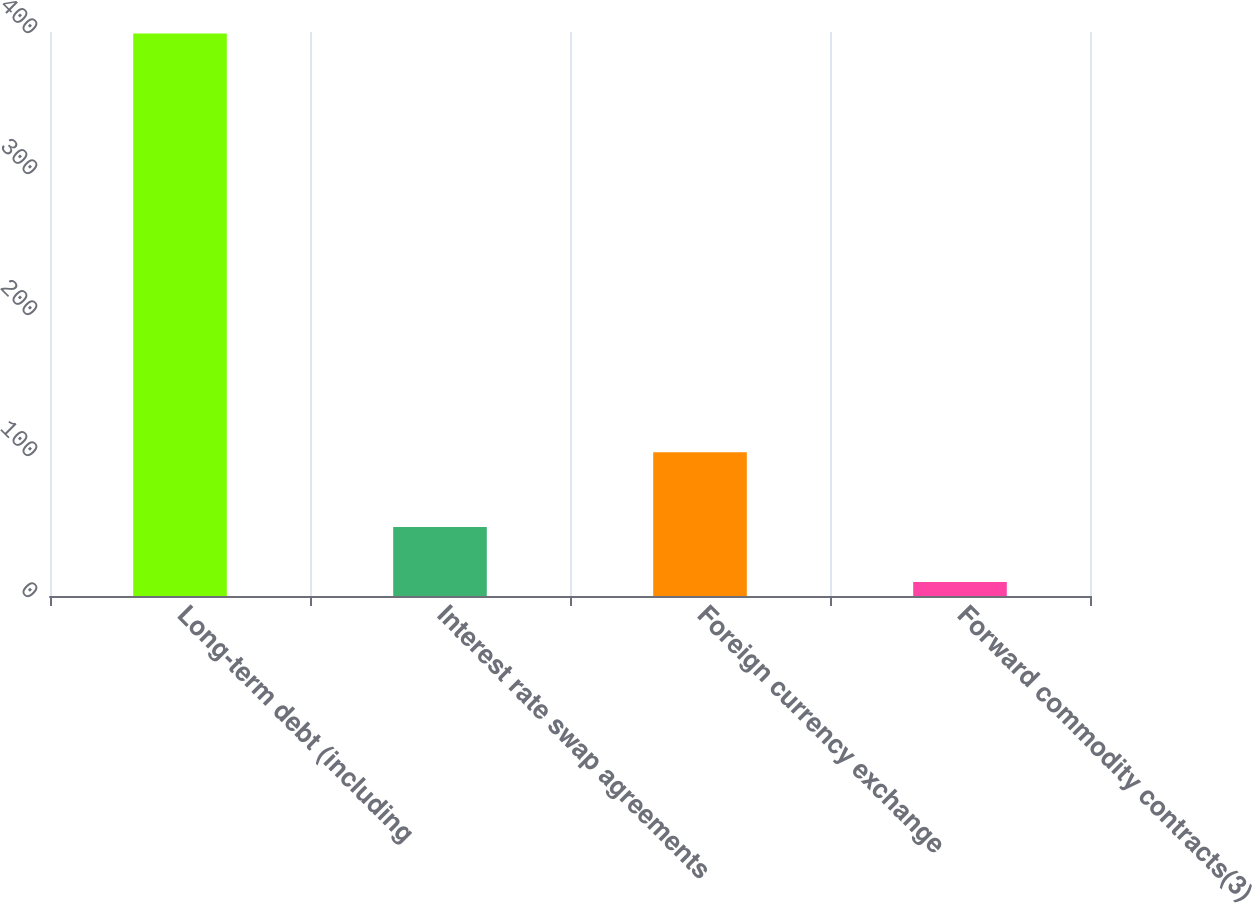Convert chart to OTSL. <chart><loc_0><loc_0><loc_500><loc_500><bar_chart><fcel>Long-term debt (including<fcel>Interest rate swap agreements<fcel>Foreign currency exchange<fcel>Forward commodity contracts(3)<nl><fcel>399<fcel>48.9<fcel>102<fcel>10<nl></chart> 